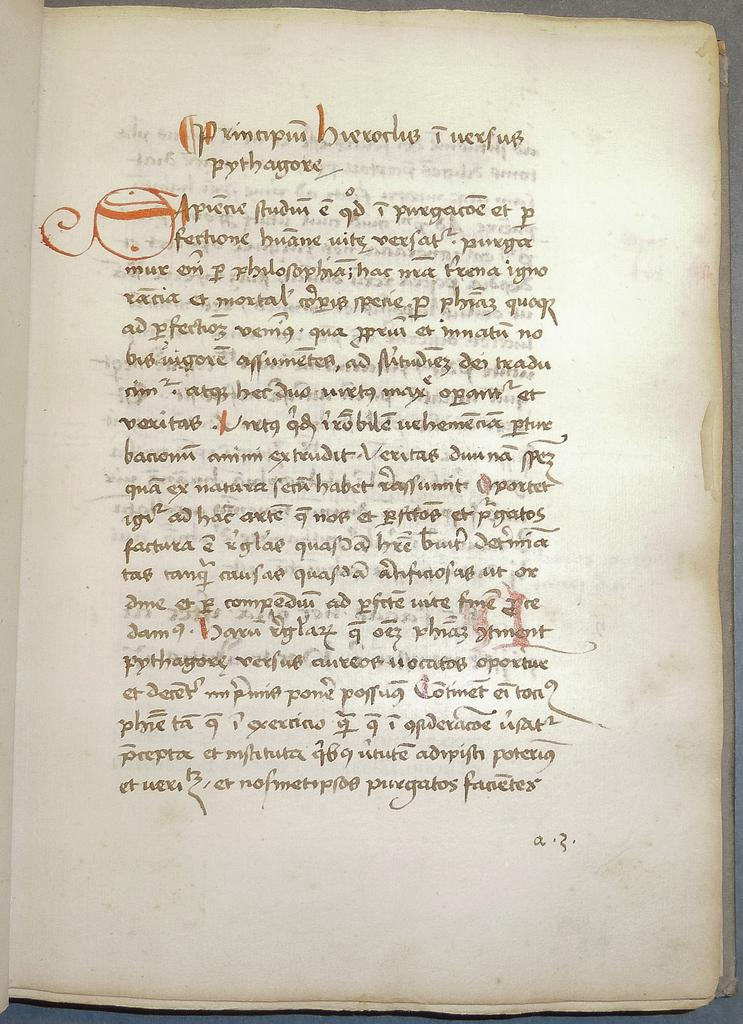<image>
Summarize the visual content of the image. A page from an old book written in a foreign language and a.3. written on the lower right portion of the page. 